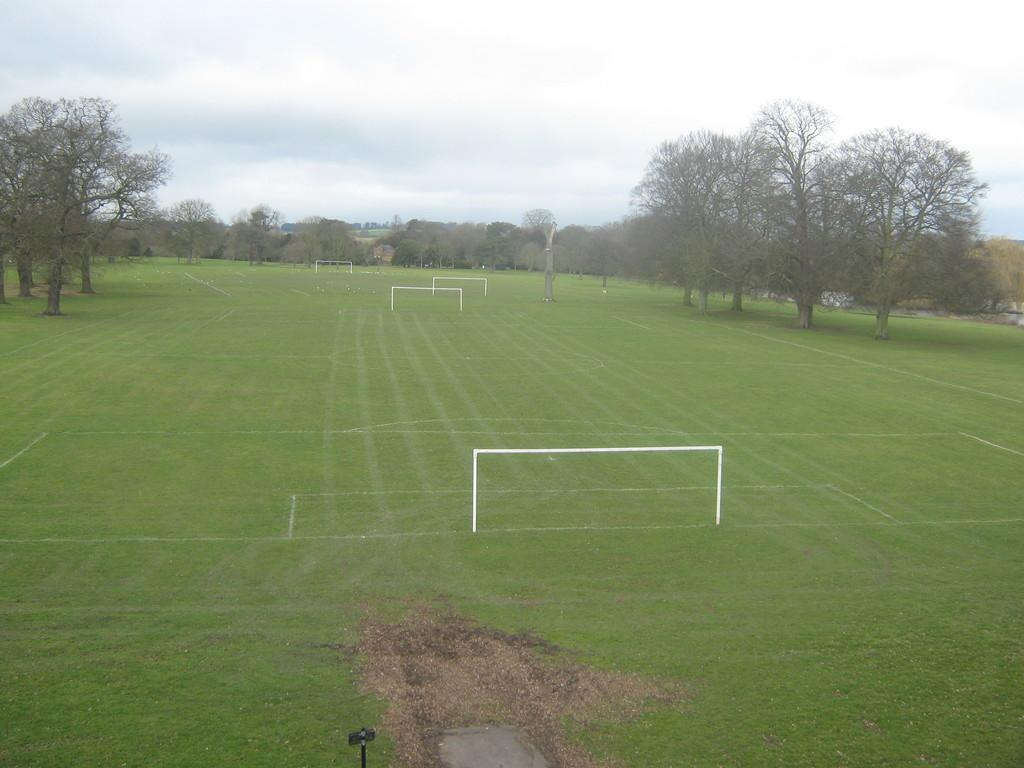How many football grounds are visible in the image? There are two football grounds in the image. What can be seen in the background of the image? There are many trees in the background of the image. What is the tax rate for the football grounds in the image? There is no information about tax rates in the image, as it only shows two football grounds and trees in the background. 